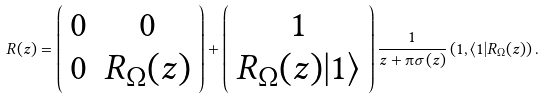Convert formula to latex. <formula><loc_0><loc_0><loc_500><loc_500>R ( z ) = \left ( \begin{array} { c c } 0 & 0 \\ 0 & R _ { \Omega } ( z ) \end{array} \right ) + \left ( \begin{array} { c } 1 \\ R _ { \Omega } ( z ) | 1 \rangle \end{array} \right ) \frac { 1 } { z + \i \sigma ( z ) } \left ( 1 , \langle 1 | R _ { \Omega } ( z ) \right ) .</formula> 